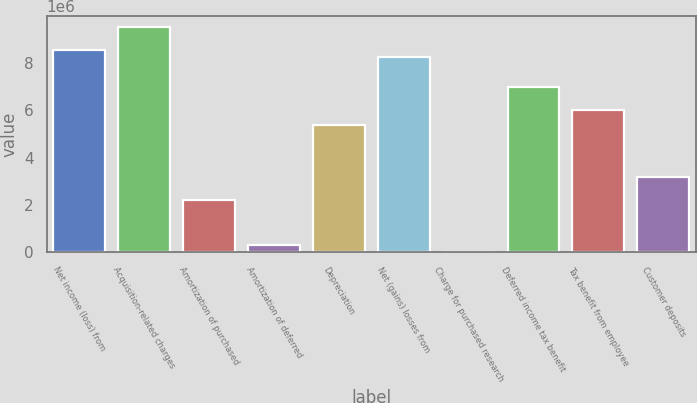Convert chart. <chart><loc_0><loc_0><loc_500><loc_500><bar_chart><fcel>Net income (loss) from<fcel>Acquisition-related charges<fcel>Amortization of purchased<fcel>Amortization of deferred<fcel>Depreciation<fcel>Net (gains) losses from<fcel>Charge for purchased research<fcel>Deferred income tax benefit<fcel>Tax benefit from employee<fcel>Customer deposits<nl><fcel>8.55706e+06<fcel>9.50781e+06<fcel>2.21867e+06<fcel>317157<fcel>5.38786e+06<fcel>8.24014e+06<fcel>238<fcel>6.97246e+06<fcel>6.0217e+06<fcel>3.16943e+06<nl></chart> 